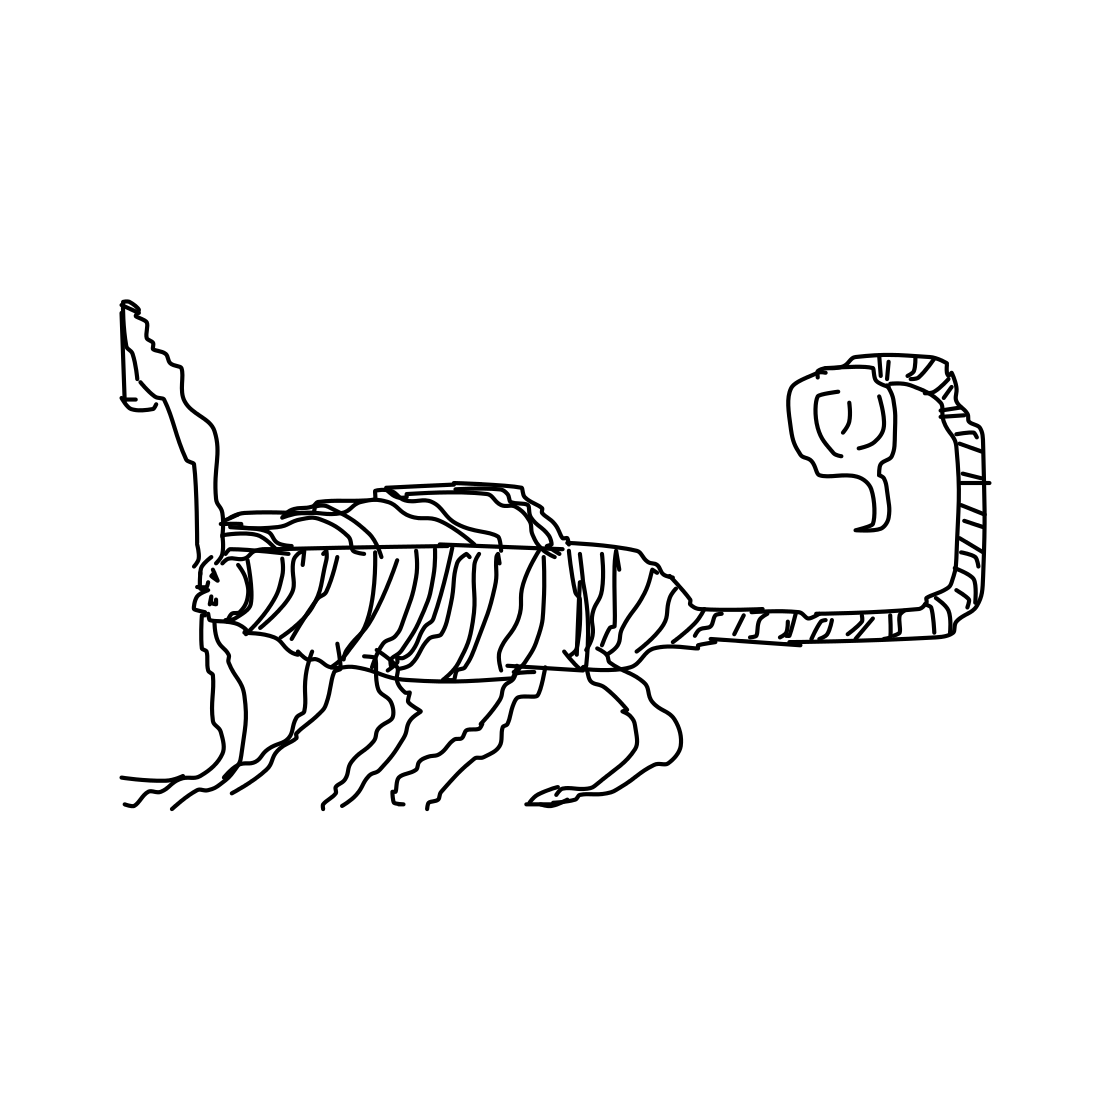What kind of art style is represented in this image? The image showcases a minimalist line drawing with an abstract and imaginative style. It embraces simplicity and appears to experiment with the fusion of elements from different animals. 